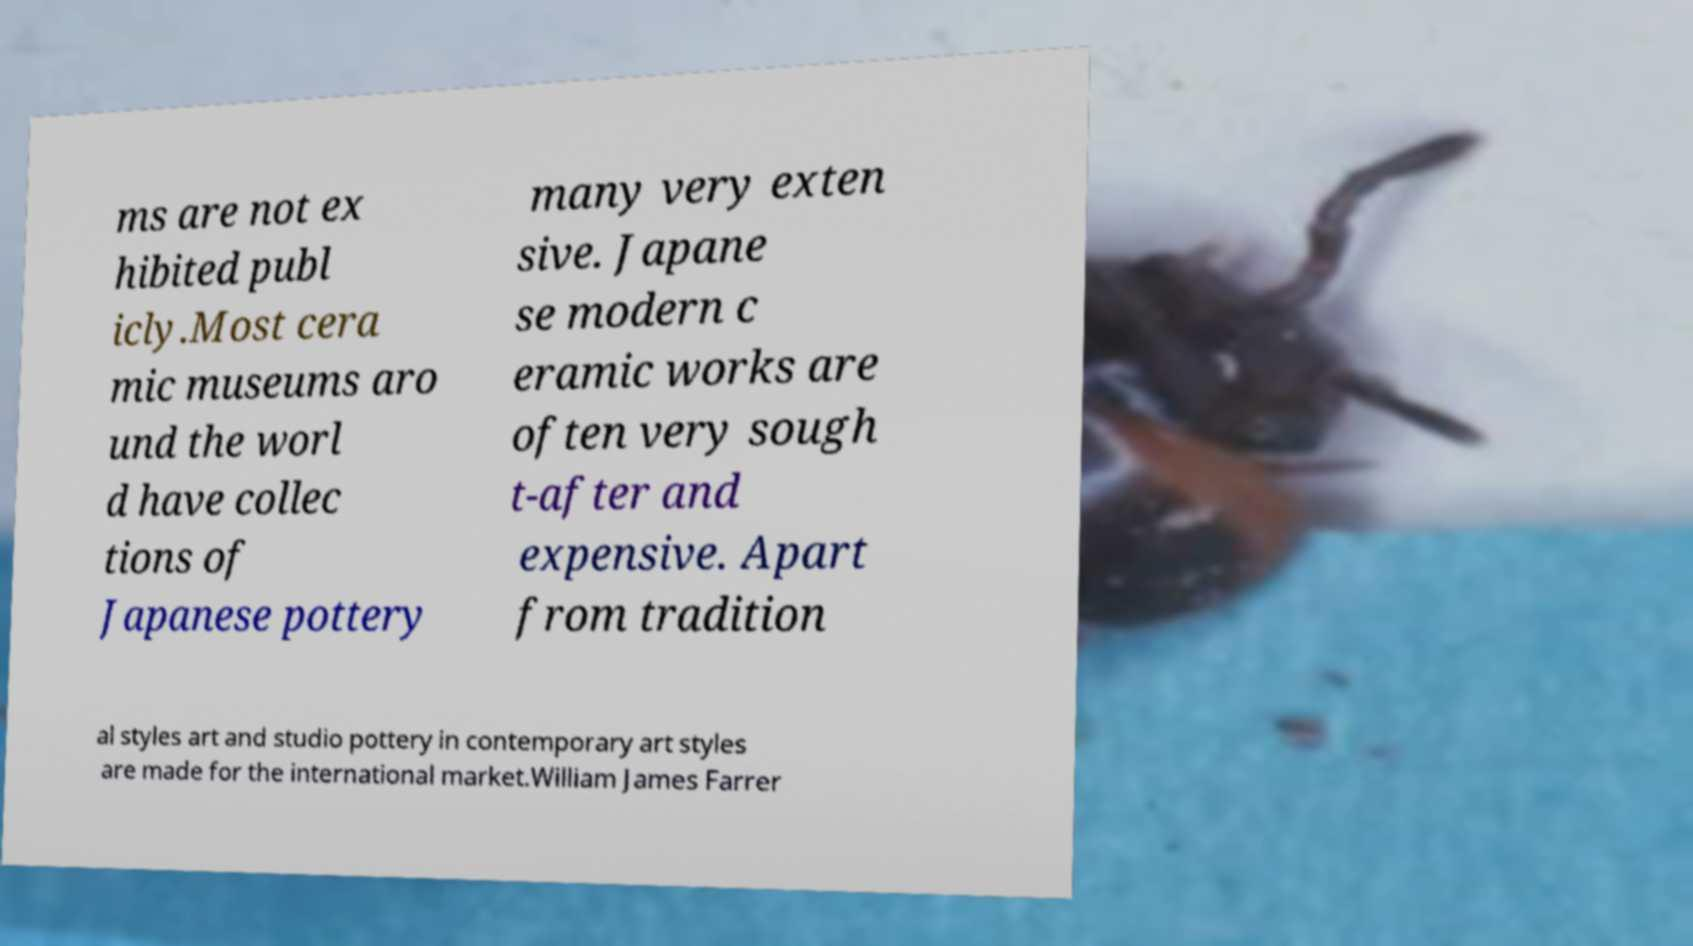There's text embedded in this image that I need extracted. Can you transcribe it verbatim? ms are not ex hibited publ icly.Most cera mic museums aro und the worl d have collec tions of Japanese pottery many very exten sive. Japane se modern c eramic works are often very sough t-after and expensive. Apart from tradition al styles art and studio pottery in contemporary art styles are made for the international market.William James Farrer 